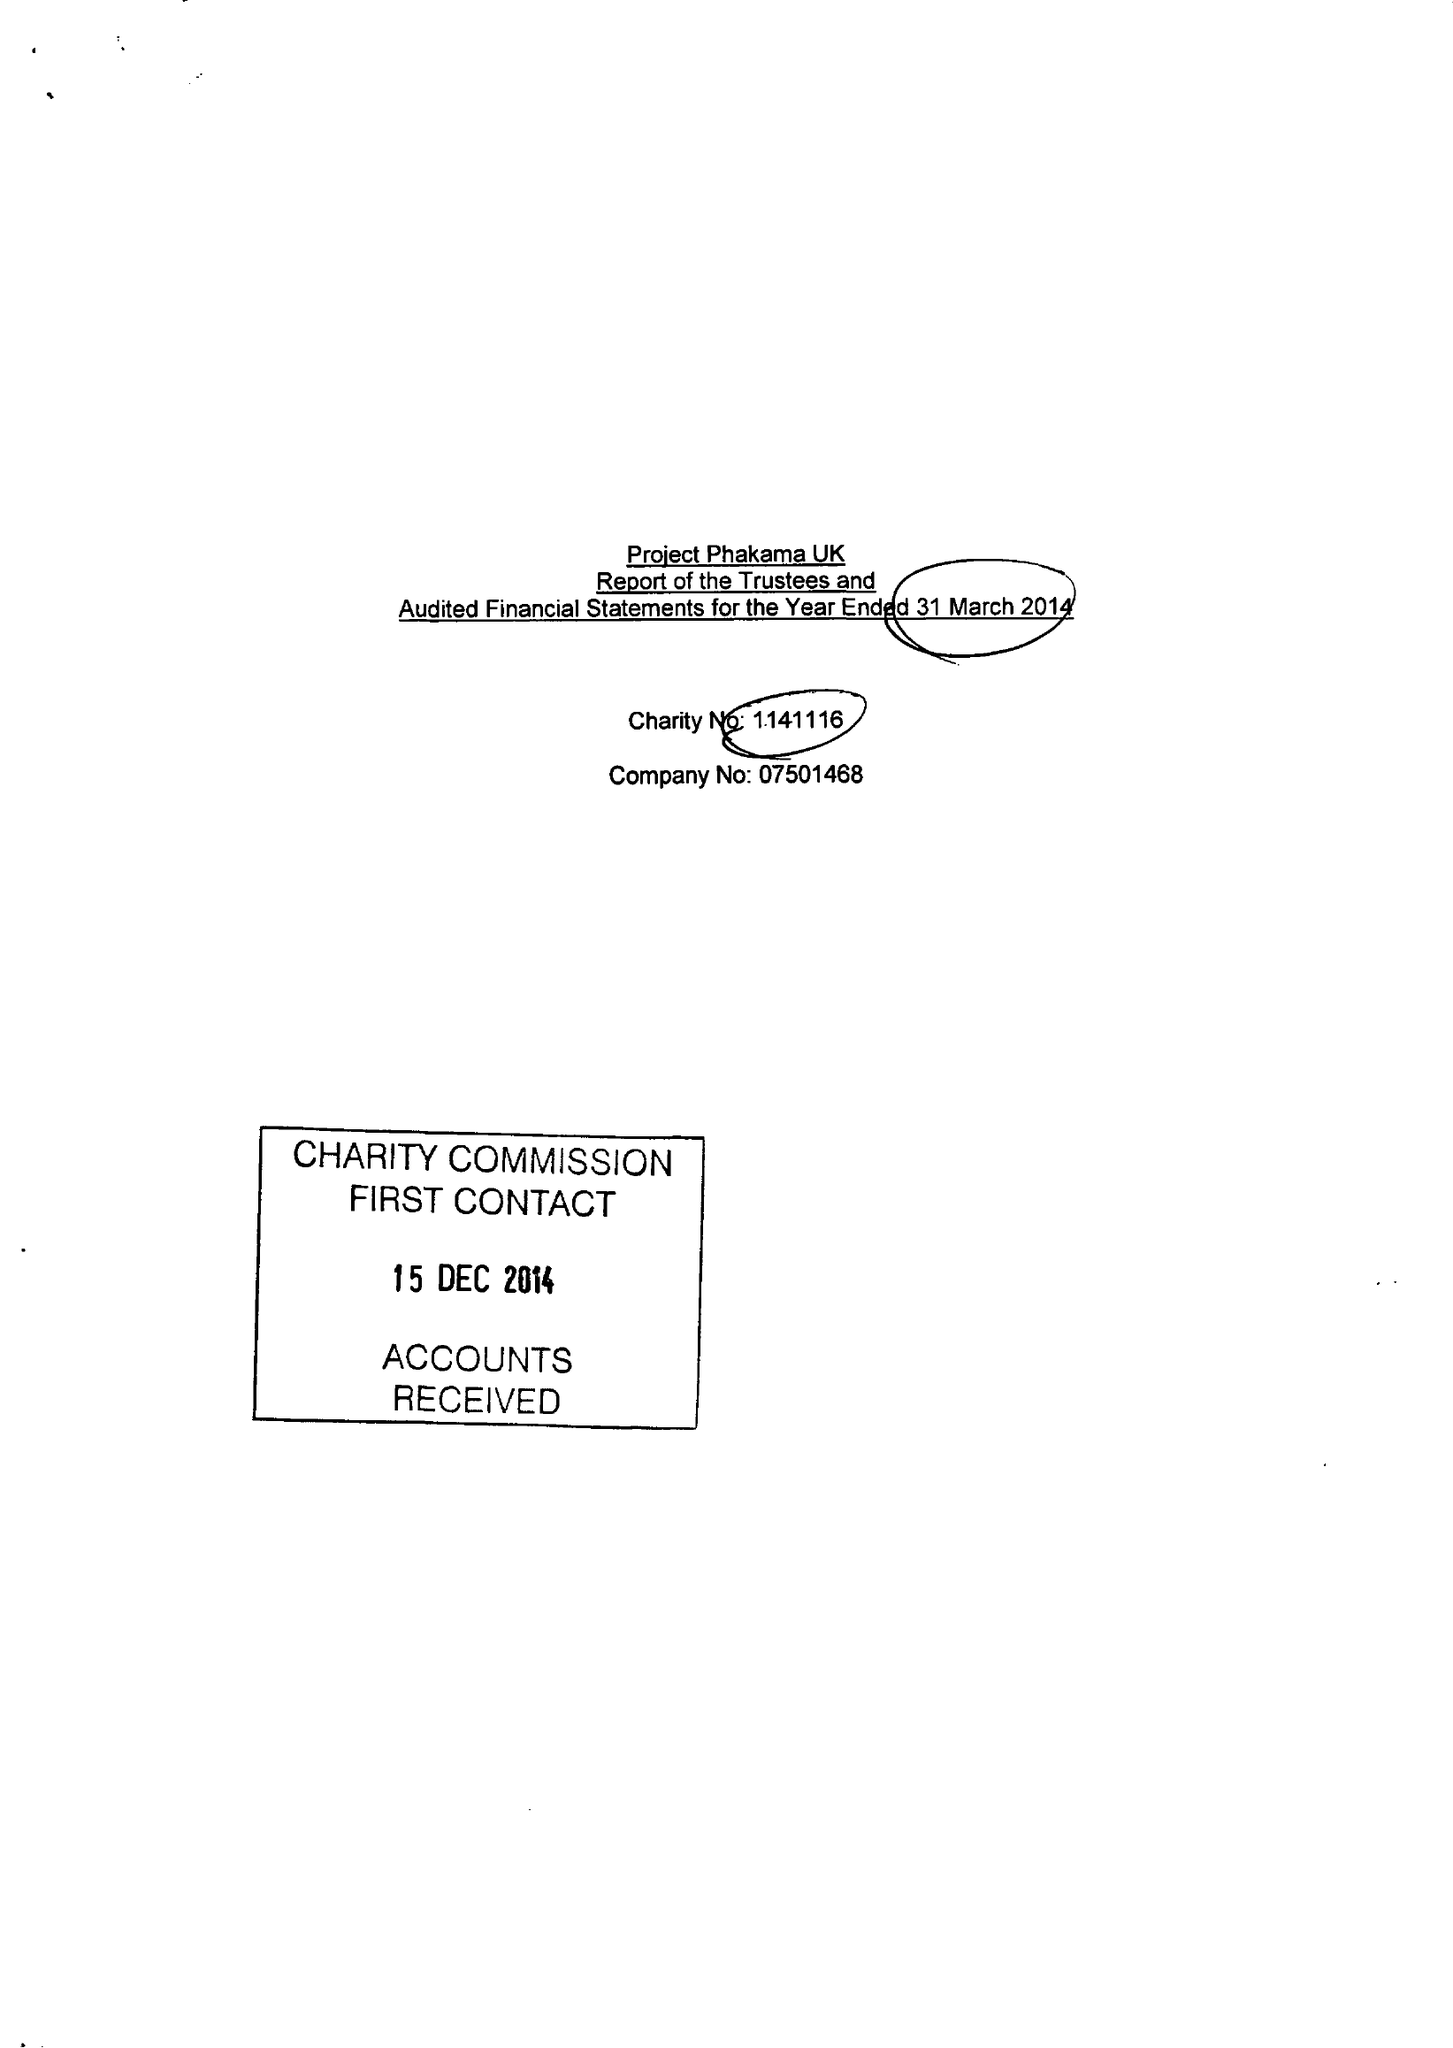What is the value for the address__street_line?
Answer the question using a single word or phrase. 327 MILE END ROAD 